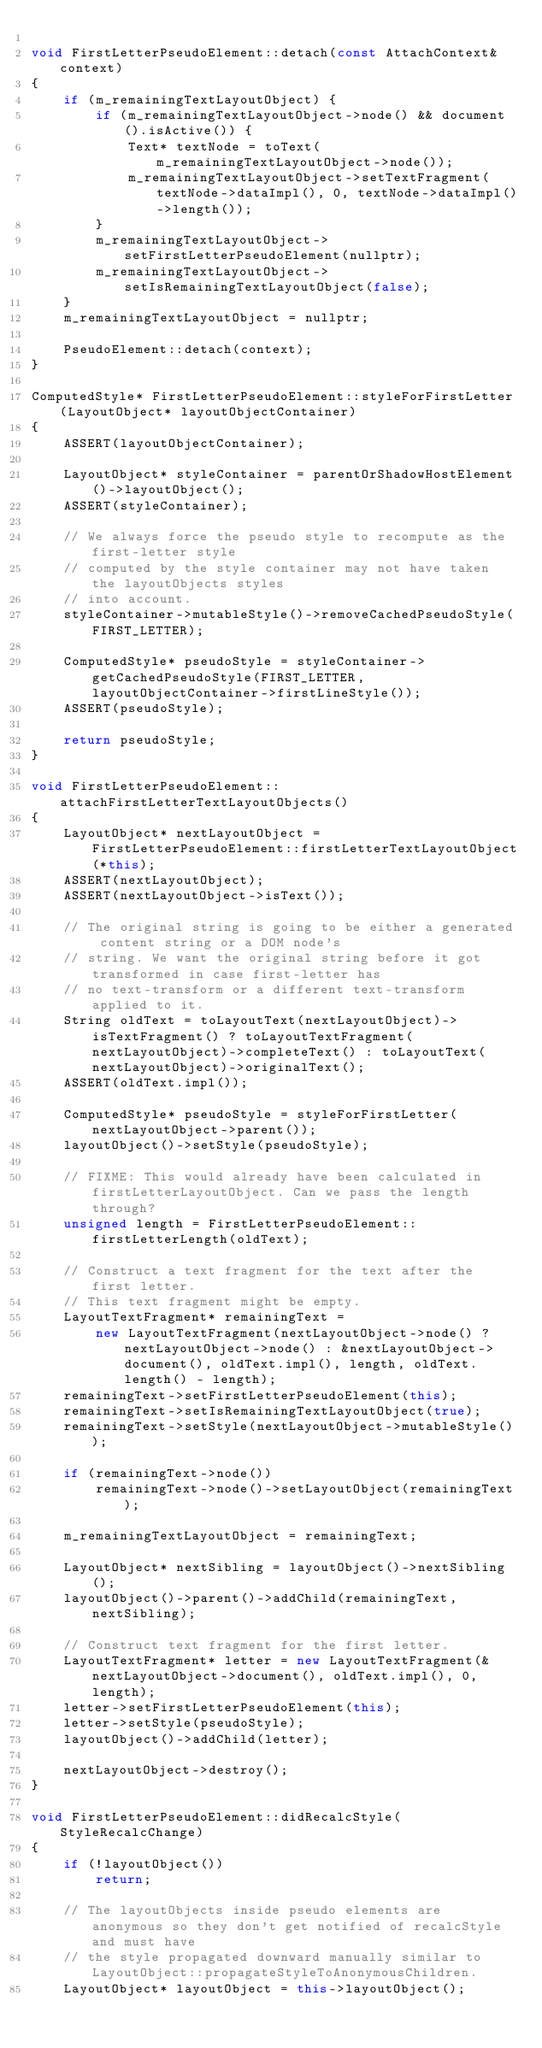Convert code to text. <code><loc_0><loc_0><loc_500><loc_500><_C++_>
void FirstLetterPseudoElement::detach(const AttachContext& context)
{
    if (m_remainingTextLayoutObject) {
        if (m_remainingTextLayoutObject->node() && document().isActive()) {
            Text* textNode = toText(m_remainingTextLayoutObject->node());
            m_remainingTextLayoutObject->setTextFragment(textNode->dataImpl(), 0, textNode->dataImpl()->length());
        }
        m_remainingTextLayoutObject->setFirstLetterPseudoElement(nullptr);
        m_remainingTextLayoutObject->setIsRemainingTextLayoutObject(false);
    }
    m_remainingTextLayoutObject = nullptr;

    PseudoElement::detach(context);
}

ComputedStyle* FirstLetterPseudoElement::styleForFirstLetter(LayoutObject* layoutObjectContainer)
{
    ASSERT(layoutObjectContainer);

    LayoutObject* styleContainer = parentOrShadowHostElement()->layoutObject();
    ASSERT(styleContainer);

    // We always force the pseudo style to recompute as the first-letter style
    // computed by the style container may not have taken the layoutObjects styles
    // into account.
    styleContainer->mutableStyle()->removeCachedPseudoStyle(FIRST_LETTER);

    ComputedStyle* pseudoStyle = styleContainer->getCachedPseudoStyle(FIRST_LETTER, layoutObjectContainer->firstLineStyle());
    ASSERT(pseudoStyle);

    return pseudoStyle;
}

void FirstLetterPseudoElement::attachFirstLetterTextLayoutObjects()
{
    LayoutObject* nextLayoutObject = FirstLetterPseudoElement::firstLetterTextLayoutObject(*this);
    ASSERT(nextLayoutObject);
    ASSERT(nextLayoutObject->isText());

    // The original string is going to be either a generated content string or a DOM node's
    // string. We want the original string before it got transformed in case first-letter has
    // no text-transform or a different text-transform applied to it.
    String oldText = toLayoutText(nextLayoutObject)->isTextFragment() ? toLayoutTextFragment(nextLayoutObject)->completeText() : toLayoutText(nextLayoutObject)->originalText();
    ASSERT(oldText.impl());

    ComputedStyle* pseudoStyle = styleForFirstLetter(nextLayoutObject->parent());
    layoutObject()->setStyle(pseudoStyle);

    // FIXME: This would already have been calculated in firstLetterLayoutObject. Can we pass the length through?
    unsigned length = FirstLetterPseudoElement::firstLetterLength(oldText);

    // Construct a text fragment for the text after the first letter.
    // This text fragment might be empty.
    LayoutTextFragment* remainingText =
        new LayoutTextFragment(nextLayoutObject->node() ? nextLayoutObject->node() : &nextLayoutObject->document(), oldText.impl(), length, oldText.length() - length);
    remainingText->setFirstLetterPseudoElement(this);
    remainingText->setIsRemainingTextLayoutObject(true);
    remainingText->setStyle(nextLayoutObject->mutableStyle());

    if (remainingText->node())
        remainingText->node()->setLayoutObject(remainingText);

    m_remainingTextLayoutObject = remainingText;

    LayoutObject* nextSibling = layoutObject()->nextSibling();
    layoutObject()->parent()->addChild(remainingText, nextSibling);

    // Construct text fragment for the first letter.
    LayoutTextFragment* letter = new LayoutTextFragment(&nextLayoutObject->document(), oldText.impl(), 0, length);
    letter->setFirstLetterPseudoElement(this);
    letter->setStyle(pseudoStyle);
    layoutObject()->addChild(letter);

    nextLayoutObject->destroy();
}

void FirstLetterPseudoElement::didRecalcStyle(StyleRecalcChange)
{
    if (!layoutObject())
        return;

    // The layoutObjects inside pseudo elements are anonymous so they don't get notified of recalcStyle and must have
    // the style propagated downward manually similar to LayoutObject::propagateStyleToAnonymousChildren.
    LayoutObject* layoutObject = this->layoutObject();</code> 